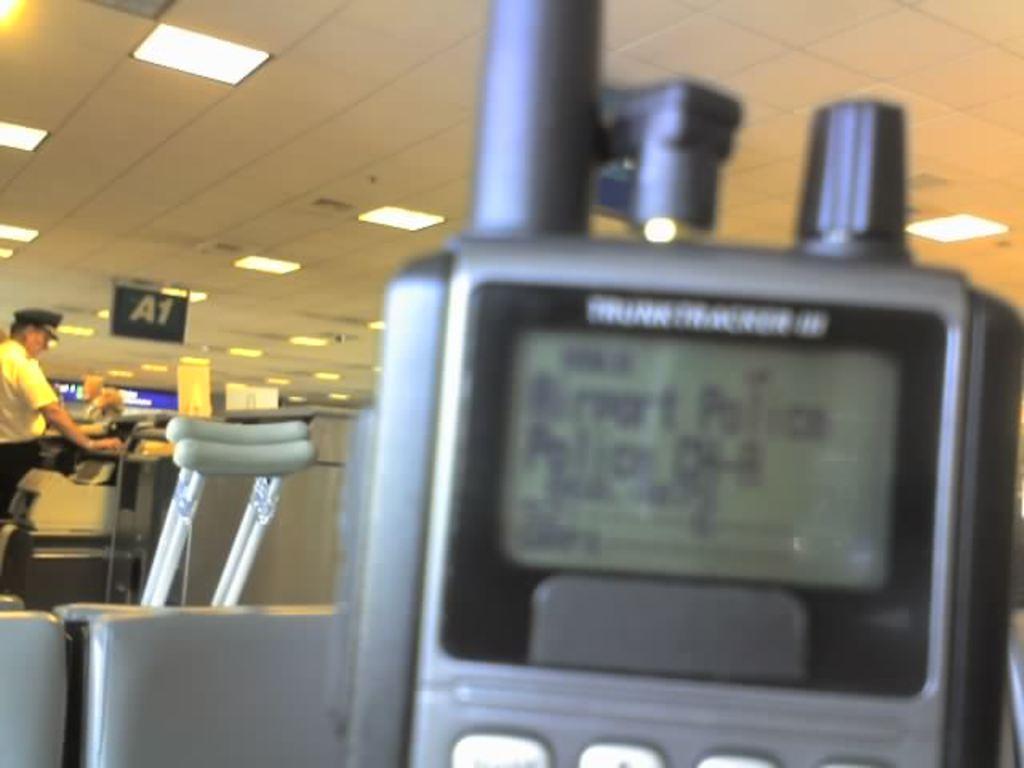How would you summarize this image in a sentence or two? In this image, I can see a walkie talkie and Axillary Crutches. On the left side of the image, I can see a machine and a person standing. At the top of the image, I can see the ceiling lights and a board attached to the ceiling. 